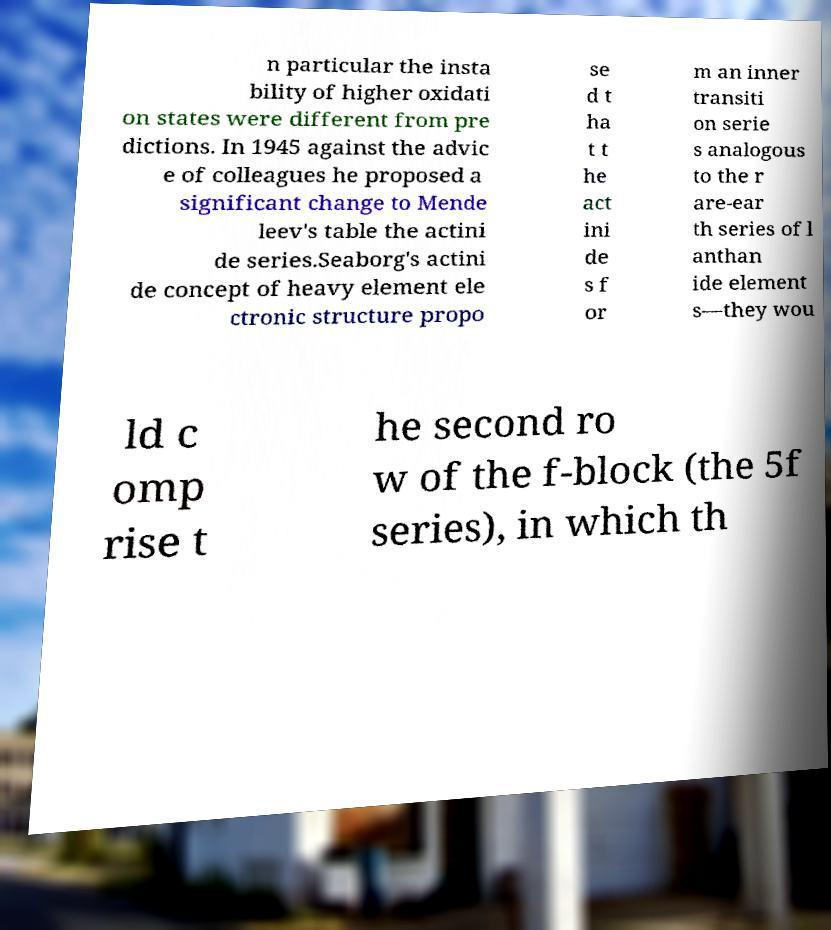Could you extract and type out the text from this image? n particular the insta bility of higher oxidati on states were different from pre dictions. In 1945 against the advic e of colleagues he proposed a significant change to Mende leev's table the actini de series.Seaborg's actini de concept of heavy element ele ctronic structure propo se d t ha t t he act ini de s f or m an inner transiti on serie s analogous to the r are-ear th series of l anthan ide element s—they wou ld c omp rise t he second ro w of the f-block (the 5f series), in which th 